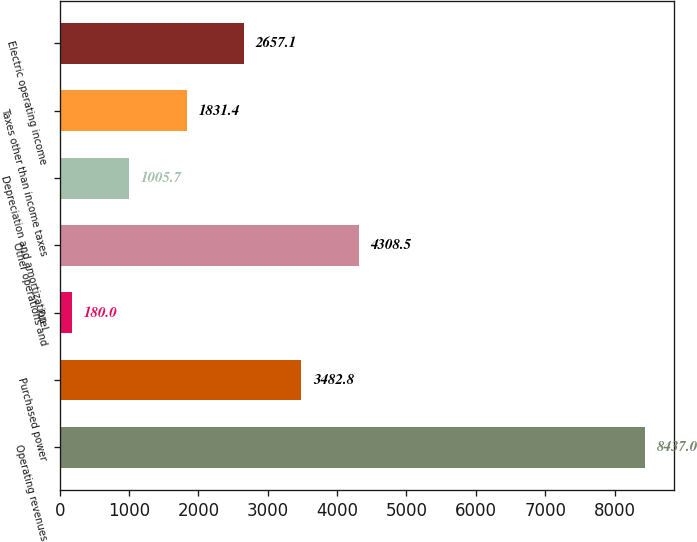Convert chart to OTSL. <chart><loc_0><loc_0><loc_500><loc_500><bar_chart><fcel>Operating revenues<fcel>Purchased power<fcel>Fuel<fcel>Other operations and<fcel>Depreciation and amortization<fcel>Taxes other than income taxes<fcel>Electric operating income<nl><fcel>8437<fcel>3482.8<fcel>180<fcel>4308.5<fcel>1005.7<fcel>1831.4<fcel>2657.1<nl></chart> 